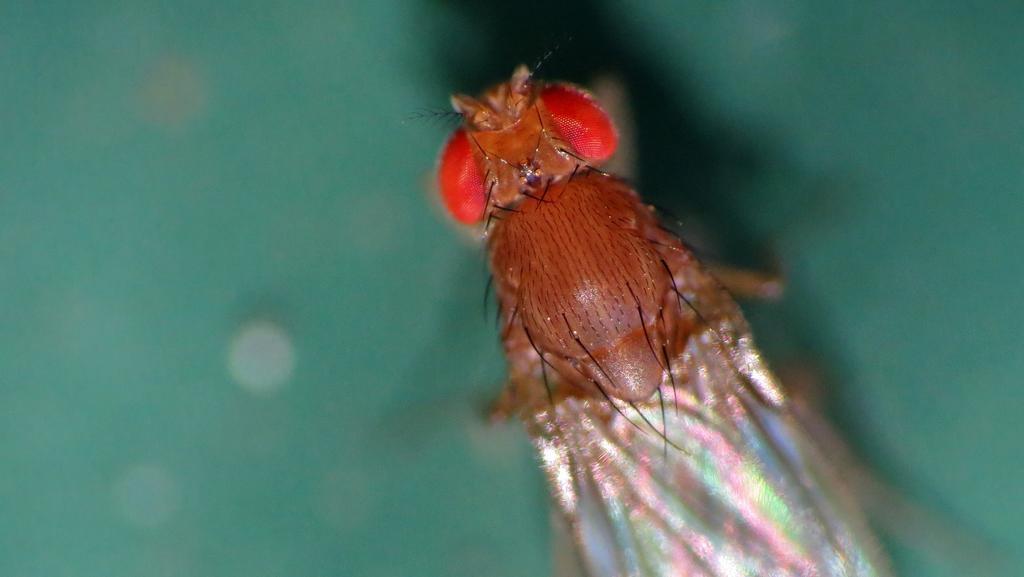Can you describe this image briefly? In this image there is an insect. 